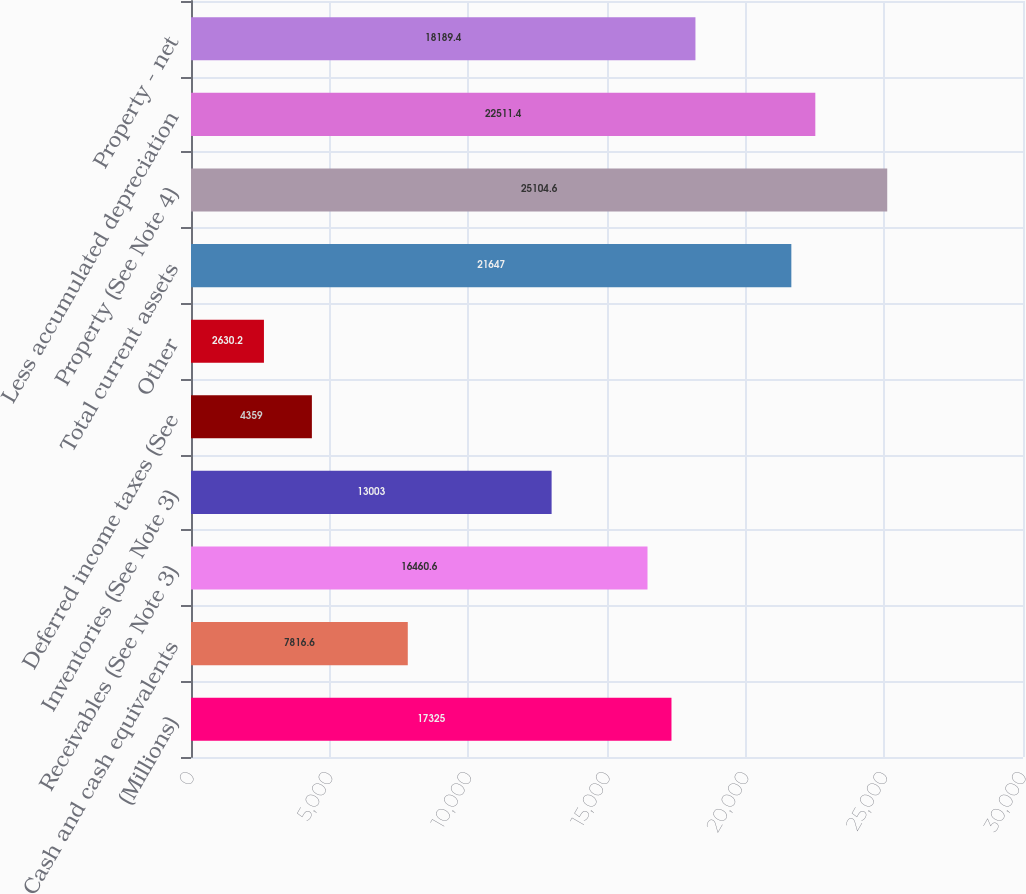Convert chart. <chart><loc_0><loc_0><loc_500><loc_500><bar_chart><fcel>(Millions)<fcel>Cash and cash equivalents<fcel>Receivables (See Note 3)<fcel>Inventories (See Note 3)<fcel>Deferred income taxes (See<fcel>Other<fcel>Total current assets<fcel>Property (See Note 4)<fcel>Less accumulated depreciation<fcel>Property - net<nl><fcel>17325<fcel>7816.6<fcel>16460.6<fcel>13003<fcel>4359<fcel>2630.2<fcel>21647<fcel>25104.6<fcel>22511.4<fcel>18189.4<nl></chart> 